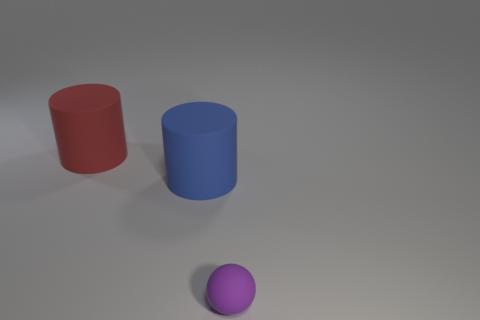Add 1 small shiny spheres. How many objects exist? 4 Subtract all cylinders. How many objects are left? 1 Subtract 0 gray blocks. How many objects are left? 3 Subtract all red metallic cubes. Subtract all matte balls. How many objects are left? 2 Add 3 large blue matte things. How many large blue matte things are left? 4 Add 3 large yellow cylinders. How many large yellow cylinders exist? 3 